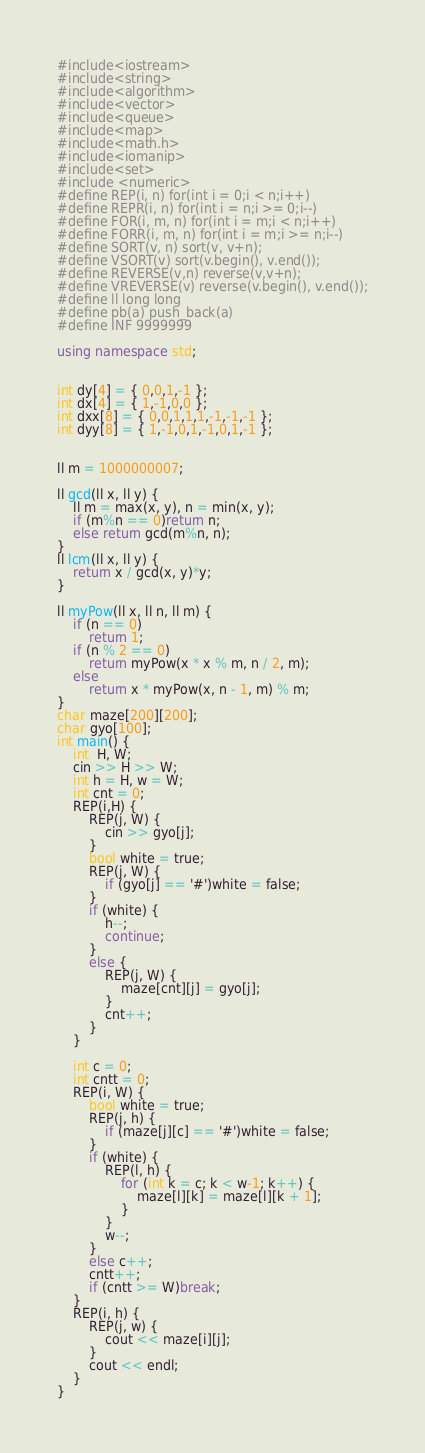<code> <loc_0><loc_0><loc_500><loc_500><_C++_>
#include<iostream>
#include<string>
#include<algorithm>
#include<vector>
#include<queue>
#include<map>
#include<math.h>
#include<iomanip>
#include<set>
#include <numeric>
#define REP(i, n) for(int i = 0;i < n;i++)
#define REPR(i, n) for(int i = n;i >= 0;i--)
#define FOR(i, m, n) for(int i = m;i < n;i++)
#define FORR(i, m, n) for(int i = m;i >= n;i--)
#define SORT(v, n) sort(v, v+n);
#define VSORT(v) sort(v.begin(), v.end());
#define REVERSE(v,n) reverse(v,v+n);
#define VREVERSE(v) reverse(v.begin(), v.end());
#define ll long long
#define pb(a) push_back(a)
#define INF 9999999

using namespace std;


int dy[4] = { 0,0,1,-1 };
int dx[4] = { 1,-1,0,0 };
int dxx[8] = { 0,0,1,1,1,-1,-1,-1 };
int dyy[8] = { 1,-1,0,1,-1,0,1,-1 };


ll m = 1000000007;

ll gcd(ll x, ll y) {
	ll m = max(x, y), n = min(x, y);
	if (m%n == 0)return n;
	else return gcd(m%n, n);
}
ll lcm(ll x, ll y) {
	return x / gcd(x, y)*y;
}

ll myPow(ll x, ll n, ll m) {
	if (n == 0)
		return 1;
	if (n % 2 == 0)
		return myPow(x * x % m, n / 2, m);
	else
		return x * myPow(x, n - 1, m) % m;
}
char maze[200][200];
char gyo[100];
int main() {
	int  H, W;
	cin >> H >> W;
	int h = H, w = W;
	int cnt = 0;
	REP(i,H) {
		REP(j, W) {
			cin >> gyo[j];
		}
		bool white = true;
		REP(j, W) {
			if (gyo[j] == '#')white = false;
		}
		if (white) {
			h--;
			continue;
		}
		else {
			REP(j, W) {
				maze[cnt][j] = gyo[j];
			}
			cnt++;
		}
	}

	int c = 0;
	int cntt = 0;
	REP(i, W) {
		bool white = true;
		REP(j, h) {
			if (maze[j][c] == '#')white = false;
		}
		if (white) {
			REP(l, h) {
				for (int k = c; k < w-1; k++) {
					maze[l][k] = maze[l][k + 1];
				}
			}
			w--;
		}
		else c++;
		cntt++;
		if (cntt >= W)break;
	}
	REP(i, h) {
		REP(j, w) {
			cout << maze[i][j];
		}
		cout << endl;
	}
}
</code> 